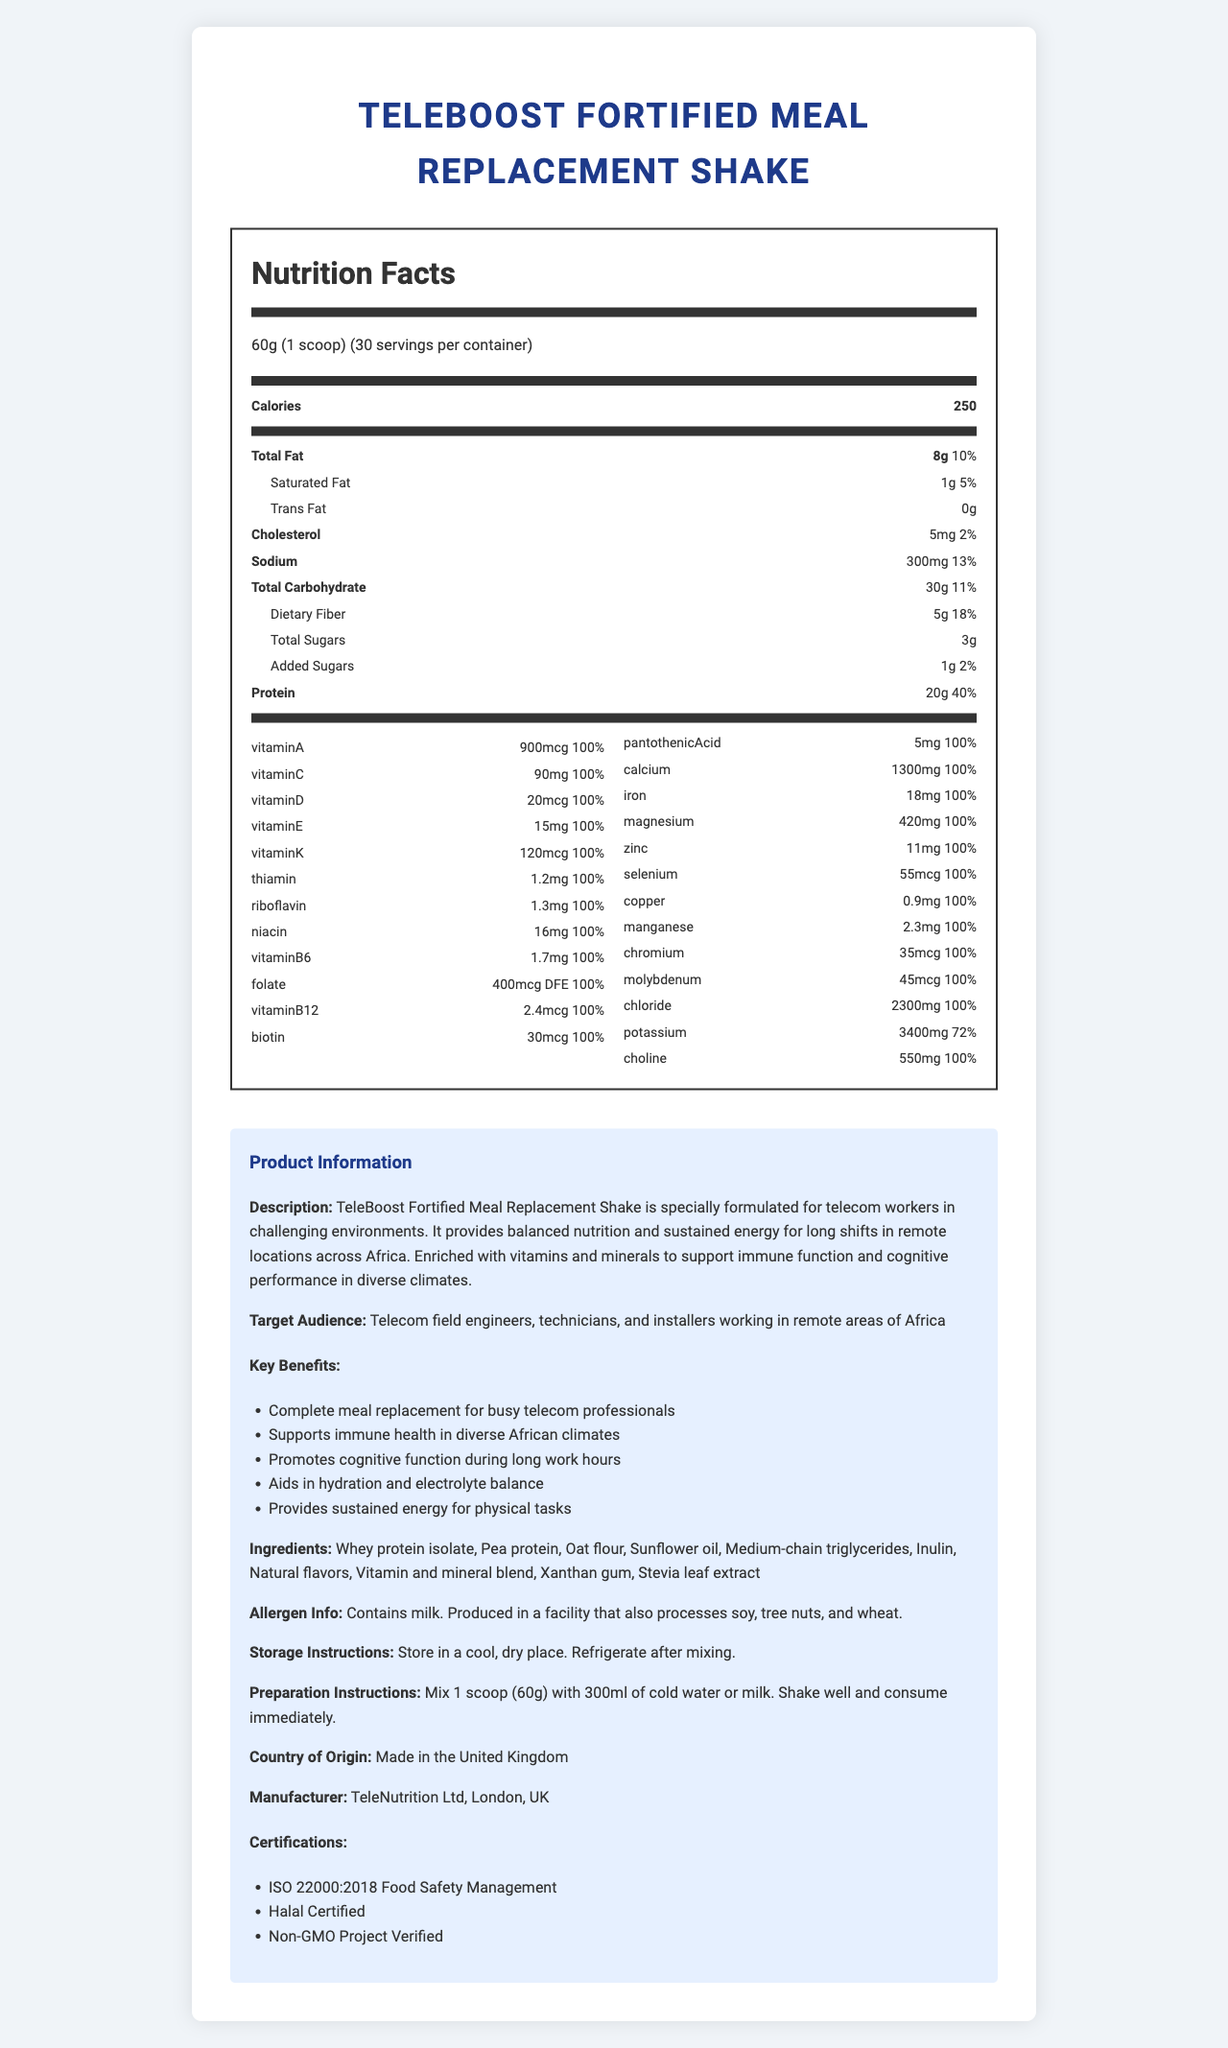what is the serving size? The document lists "60g (1 scoop)" as the serving size at the top of the nutrition facts.
Answer: 60g (1 scoop) how many servings are in each container? The document specifies that there are 30 servings per container.
Answer: 30 servings how many calories are in one serving? The nutrition facts show that each serving contains 250 calories.
Answer: 250 calories what percentage of the daily value for protein does one serving provide? The document states that one serving provides 20g of protein, which is 40% of the daily value.
Answer: 40% which vitamins are included in 100% of the daily value per serving? The vitamins listed in the document all provide 100% of the daily value per serving.
Answer: Vitamin A, Vitamin C, Vitamin D, Vitamin E, Vitamin K, Thiamin, Riboflavin, Niacin, Vitamin B6, Folate, Vitamin B12, Biotin, Pantothenic Acid, Calcium, Iron, Magnesium, Zinc, Selenium, Copper, Manganese, Chromium, Molybdenum, Chloride, Choline what is the total fat content per serving? The document lists 8g as the total fat content per serving.
Answer: 8g how much sodium is in each serving? The document indicates that each serving contains 300mg of sodium.
Answer: 300mg what are the three main protein sources in this meal replacement shake? A. Whey protein isolate, Pea protein, Oat flour B. Whey protein isolate, Soy protein, Oat flour C. Pea protein, Soy protein, Whey protein isolate D. Oat flour, Whey protein isolate, Soy protein The ingredients list mentions "Whey protein isolate", "Pea protein", and "Oat flour" as the main protein sources.
Answer: A which of the following is not an ingredient in TeleBoost Fortified Meal Replacement Shake? I. Xanthan Gum II. Stevia leaf extract III. Guar Gum IV. Inulin The ingredient list includes Xanthan Gum, Stevia leaf extract, and Inulin, but not Guar Gum.
Answer: III does the product contain any allergens? The allergen information states that the product contains milk and is produced in a facility that also processes soy, tree nuts, and wheat.
Answer: Yes summarize the document. The document includes detailed nutrition facts, highlighting the vitamin and mineral profile, ingredient list, allergen information, and key benefits aimed at telecom workers in Africa. It also provides storage and preparation instructions along with a product description and manufacturer information.
Answer: TeleBoost Fortified Meal Replacement Shake is a specially formulated meal replacement designed for telecom workers in challenging environments. It offers balanced nutrition with 250 calories per serving, 20g of protein, and essential vitamins and minerals, many at 100% of the daily value. The product supports immune health, cognitive function, and sustained energy, specifically targeting telecom professionals working in remote African areas. It's manufactured by TeleNutrition Ltd in the UK and holds various certifications. what is the amount of potassium in each serving and how does it compare to the daily value percentage? Each serving provides 3400mg of potassium, which is 72% of the daily value.
Answer: 3400mg, 72% can the exact protein blend ratio be determined from the document? The document lists the types of proteins (Whey protein isolate, Pea protein, Oat flour) but does not provide specific ratios for the blend.
Answer: Not enough information does the product support hydration and electrolyte balance? One of the key benefits mentioned includes supporting hydration and electrolyte balance.
Answer: Yes 